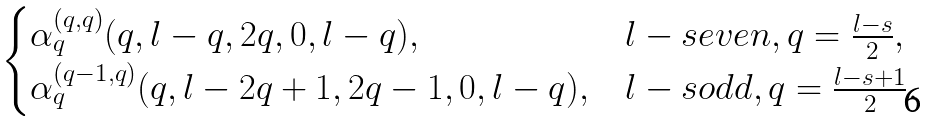Convert formula to latex. <formula><loc_0><loc_0><loc_500><loc_500>\begin{cases} \alpha _ { q } ^ { ( q , q ) } ( q , l - q , 2 q , 0 , l - q ) , & l - s e v e n , q = \frac { l - s } { 2 } , \\ \alpha _ { q } ^ { ( q - 1 , q ) } ( q , l - 2 q + 1 , 2 q - 1 , 0 , l - q ) , & l - s o d d , q = \frac { l - s + 1 } { 2 } . \end{cases}</formula> 